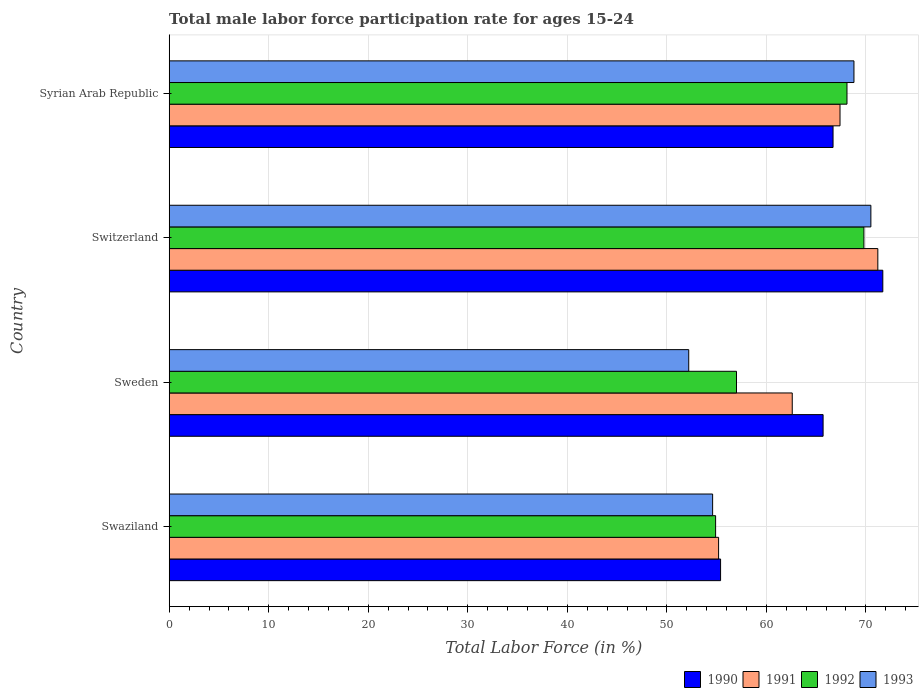How many different coloured bars are there?
Ensure brevity in your answer.  4. How many groups of bars are there?
Offer a very short reply. 4. Are the number of bars on each tick of the Y-axis equal?
Offer a terse response. Yes. What is the label of the 1st group of bars from the top?
Provide a succinct answer. Syrian Arab Republic. In how many cases, is the number of bars for a given country not equal to the number of legend labels?
Offer a very short reply. 0. What is the male labor force participation rate in 1990 in Swaziland?
Make the answer very short. 55.4. Across all countries, what is the maximum male labor force participation rate in 1992?
Offer a terse response. 69.8. Across all countries, what is the minimum male labor force participation rate in 1990?
Offer a very short reply. 55.4. In which country was the male labor force participation rate in 1990 maximum?
Your answer should be compact. Switzerland. In which country was the male labor force participation rate in 1990 minimum?
Make the answer very short. Swaziland. What is the total male labor force participation rate in 1991 in the graph?
Provide a succinct answer. 256.4. What is the difference between the male labor force participation rate in 1992 in Sweden and that in Syrian Arab Republic?
Your answer should be compact. -11.1. What is the difference between the male labor force participation rate in 1990 in Switzerland and the male labor force participation rate in 1991 in Swaziland?
Offer a terse response. 16.5. What is the average male labor force participation rate in 1993 per country?
Your response must be concise. 61.53. What is the difference between the male labor force participation rate in 1991 and male labor force participation rate in 1993 in Swaziland?
Provide a short and direct response. 0.6. What is the ratio of the male labor force participation rate in 1992 in Switzerland to that in Syrian Arab Republic?
Provide a succinct answer. 1.02. What is the difference between the highest and the second highest male labor force participation rate in 1993?
Make the answer very short. 1.7. What is the difference between the highest and the lowest male labor force participation rate in 1992?
Your answer should be compact. 14.9. In how many countries, is the male labor force participation rate in 1991 greater than the average male labor force participation rate in 1991 taken over all countries?
Offer a very short reply. 2. Is it the case that in every country, the sum of the male labor force participation rate in 1991 and male labor force participation rate in 1990 is greater than the sum of male labor force participation rate in 1993 and male labor force participation rate in 1992?
Your answer should be very brief. Yes. What does the 4th bar from the top in Sweden represents?
Your answer should be very brief. 1990. What does the 3rd bar from the bottom in Syrian Arab Republic represents?
Your answer should be compact. 1992. How many bars are there?
Your answer should be compact. 16. Does the graph contain any zero values?
Your answer should be compact. No. Does the graph contain grids?
Give a very brief answer. Yes. Where does the legend appear in the graph?
Ensure brevity in your answer.  Bottom right. How many legend labels are there?
Provide a succinct answer. 4. What is the title of the graph?
Keep it short and to the point. Total male labor force participation rate for ages 15-24. Does "1975" appear as one of the legend labels in the graph?
Give a very brief answer. No. What is the Total Labor Force (in %) of 1990 in Swaziland?
Offer a terse response. 55.4. What is the Total Labor Force (in %) in 1991 in Swaziland?
Give a very brief answer. 55.2. What is the Total Labor Force (in %) in 1992 in Swaziland?
Your response must be concise. 54.9. What is the Total Labor Force (in %) in 1993 in Swaziland?
Keep it short and to the point. 54.6. What is the Total Labor Force (in %) in 1990 in Sweden?
Make the answer very short. 65.7. What is the Total Labor Force (in %) in 1991 in Sweden?
Keep it short and to the point. 62.6. What is the Total Labor Force (in %) of 1992 in Sweden?
Offer a very short reply. 57. What is the Total Labor Force (in %) in 1993 in Sweden?
Your response must be concise. 52.2. What is the Total Labor Force (in %) of 1990 in Switzerland?
Make the answer very short. 71.7. What is the Total Labor Force (in %) in 1991 in Switzerland?
Make the answer very short. 71.2. What is the Total Labor Force (in %) of 1992 in Switzerland?
Your answer should be very brief. 69.8. What is the Total Labor Force (in %) of 1993 in Switzerland?
Your answer should be very brief. 70.5. What is the Total Labor Force (in %) of 1990 in Syrian Arab Republic?
Provide a short and direct response. 66.7. What is the Total Labor Force (in %) in 1991 in Syrian Arab Republic?
Provide a succinct answer. 67.4. What is the Total Labor Force (in %) in 1992 in Syrian Arab Republic?
Give a very brief answer. 68.1. What is the Total Labor Force (in %) in 1993 in Syrian Arab Republic?
Your response must be concise. 68.8. Across all countries, what is the maximum Total Labor Force (in %) of 1990?
Make the answer very short. 71.7. Across all countries, what is the maximum Total Labor Force (in %) of 1991?
Your answer should be very brief. 71.2. Across all countries, what is the maximum Total Labor Force (in %) of 1992?
Your answer should be very brief. 69.8. Across all countries, what is the maximum Total Labor Force (in %) in 1993?
Provide a succinct answer. 70.5. Across all countries, what is the minimum Total Labor Force (in %) in 1990?
Make the answer very short. 55.4. Across all countries, what is the minimum Total Labor Force (in %) in 1991?
Give a very brief answer. 55.2. Across all countries, what is the minimum Total Labor Force (in %) in 1992?
Offer a terse response. 54.9. Across all countries, what is the minimum Total Labor Force (in %) of 1993?
Make the answer very short. 52.2. What is the total Total Labor Force (in %) in 1990 in the graph?
Your answer should be very brief. 259.5. What is the total Total Labor Force (in %) in 1991 in the graph?
Ensure brevity in your answer.  256.4. What is the total Total Labor Force (in %) of 1992 in the graph?
Your answer should be very brief. 249.8. What is the total Total Labor Force (in %) of 1993 in the graph?
Your response must be concise. 246.1. What is the difference between the Total Labor Force (in %) in 1991 in Swaziland and that in Sweden?
Ensure brevity in your answer.  -7.4. What is the difference between the Total Labor Force (in %) in 1990 in Swaziland and that in Switzerland?
Offer a terse response. -16.3. What is the difference between the Total Labor Force (in %) of 1991 in Swaziland and that in Switzerland?
Ensure brevity in your answer.  -16. What is the difference between the Total Labor Force (in %) in 1992 in Swaziland and that in Switzerland?
Your answer should be compact. -14.9. What is the difference between the Total Labor Force (in %) of 1993 in Swaziland and that in Switzerland?
Provide a succinct answer. -15.9. What is the difference between the Total Labor Force (in %) in 1991 in Sweden and that in Switzerland?
Your answer should be very brief. -8.6. What is the difference between the Total Labor Force (in %) in 1992 in Sweden and that in Switzerland?
Keep it short and to the point. -12.8. What is the difference between the Total Labor Force (in %) in 1993 in Sweden and that in Switzerland?
Provide a short and direct response. -18.3. What is the difference between the Total Labor Force (in %) in 1990 in Sweden and that in Syrian Arab Republic?
Keep it short and to the point. -1. What is the difference between the Total Labor Force (in %) in 1991 in Sweden and that in Syrian Arab Republic?
Offer a terse response. -4.8. What is the difference between the Total Labor Force (in %) in 1992 in Sweden and that in Syrian Arab Republic?
Provide a short and direct response. -11.1. What is the difference between the Total Labor Force (in %) of 1993 in Sweden and that in Syrian Arab Republic?
Provide a succinct answer. -16.6. What is the difference between the Total Labor Force (in %) in 1990 in Switzerland and that in Syrian Arab Republic?
Give a very brief answer. 5. What is the difference between the Total Labor Force (in %) of 1991 in Switzerland and that in Syrian Arab Republic?
Ensure brevity in your answer.  3.8. What is the difference between the Total Labor Force (in %) in 1993 in Switzerland and that in Syrian Arab Republic?
Your answer should be very brief. 1.7. What is the difference between the Total Labor Force (in %) of 1990 in Swaziland and the Total Labor Force (in %) of 1992 in Sweden?
Keep it short and to the point. -1.6. What is the difference between the Total Labor Force (in %) in 1991 in Swaziland and the Total Labor Force (in %) in 1992 in Sweden?
Your answer should be very brief. -1.8. What is the difference between the Total Labor Force (in %) in 1992 in Swaziland and the Total Labor Force (in %) in 1993 in Sweden?
Your response must be concise. 2.7. What is the difference between the Total Labor Force (in %) of 1990 in Swaziland and the Total Labor Force (in %) of 1991 in Switzerland?
Offer a terse response. -15.8. What is the difference between the Total Labor Force (in %) of 1990 in Swaziland and the Total Labor Force (in %) of 1992 in Switzerland?
Make the answer very short. -14.4. What is the difference between the Total Labor Force (in %) in 1990 in Swaziland and the Total Labor Force (in %) in 1993 in Switzerland?
Make the answer very short. -15.1. What is the difference between the Total Labor Force (in %) of 1991 in Swaziland and the Total Labor Force (in %) of 1992 in Switzerland?
Your answer should be compact. -14.6. What is the difference between the Total Labor Force (in %) of 1991 in Swaziland and the Total Labor Force (in %) of 1993 in Switzerland?
Ensure brevity in your answer.  -15.3. What is the difference between the Total Labor Force (in %) in 1992 in Swaziland and the Total Labor Force (in %) in 1993 in Switzerland?
Your answer should be very brief. -15.6. What is the difference between the Total Labor Force (in %) of 1990 in Swaziland and the Total Labor Force (in %) of 1991 in Syrian Arab Republic?
Keep it short and to the point. -12. What is the difference between the Total Labor Force (in %) in 1990 in Swaziland and the Total Labor Force (in %) in 1993 in Syrian Arab Republic?
Offer a terse response. -13.4. What is the difference between the Total Labor Force (in %) of 1992 in Swaziland and the Total Labor Force (in %) of 1993 in Syrian Arab Republic?
Make the answer very short. -13.9. What is the difference between the Total Labor Force (in %) of 1990 in Sweden and the Total Labor Force (in %) of 1991 in Switzerland?
Give a very brief answer. -5.5. What is the difference between the Total Labor Force (in %) of 1991 in Sweden and the Total Labor Force (in %) of 1992 in Switzerland?
Your answer should be very brief. -7.2. What is the difference between the Total Labor Force (in %) of 1991 in Sweden and the Total Labor Force (in %) of 1993 in Switzerland?
Your response must be concise. -7.9. What is the difference between the Total Labor Force (in %) in 1992 in Sweden and the Total Labor Force (in %) in 1993 in Switzerland?
Keep it short and to the point. -13.5. What is the difference between the Total Labor Force (in %) in 1990 in Sweden and the Total Labor Force (in %) in 1991 in Syrian Arab Republic?
Provide a short and direct response. -1.7. What is the difference between the Total Labor Force (in %) of 1990 in Sweden and the Total Labor Force (in %) of 1992 in Syrian Arab Republic?
Provide a short and direct response. -2.4. What is the difference between the Total Labor Force (in %) in 1990 in Sweden and the Total Labor Force (in %) in 1993 in Syrian Arab Republic?
Offer a terse response. -3.1. What is the difference between the Total Labor Force (in %) of 1991 in Sweden and the Total Labor Force (in %) of 1993 in Syrian Arab Republic?
Keep it short and to the point. -6.2. What is the difference between the Total Labor Force (in %) of 1990 in Switzerland and the Total Labor Force (in %) of 1992 in Syrian Arab Republic?
Your response must be concise. 3.6. What is the difference between the Total Labor Force (in %) of 1990 in Switzerland and the Total Labor Force (in %) of 1993 in Syrian Arab Republic?
Your answer should be very brief. 2.9. What is the difference between the Total Labor Force (in %) in 1991 in Switzerland and the Total Labor Force (in %) in 1992 in Syrian Arab Republic?
Your response must be concise. 3.1. What is the difference between the Total Labor Force (in %) of 1992 in Switzerland and the Total Labor Force (in %) of 1993 in Syrian Arab Republic?
Your answer should be very brief. 1. What is the average Total Labor Force (in %) in 1990 per country?
Make the answer very short. 64.88. What is the average Total Labor Force (in %) of 1991 per country?
Offer a very short reply. 64.1. What is the average Total Labor Force (in %) in 1992 per country?
Provide a short and direct response. 62.45. What is the average Total Labor Force (in %) of 1993 per country?
Provide a short and direct response. 61.52. What is the difference between the Total Labor Force (in %) of 1990 and Total Labor Force (in %) of 1991 in Swaziland?
Ensure brevity in your answer.  0.2. What is the difference between the Total Labor Force (in %) in 1991 and Total Labor Force (in %) in 1992 in Swaziland?
Provide a short and direct response. 0.3. What is the difference between the Total Labor Force (in %) of 1992 and Total Labor Force (in %) of 1993 in Swaziland?
Your answer should be very brief. 0.3. What is the difference between the Total Labor Force (in %) of 1990 and Total Labor Force (in %) of 1991 in Sweden?
Provide a succinct answer. 3.1. What is the difference between the Total Labor Force (in %) in 1990 and Total Labor Force (in %) in 1993 in Sweden?
Your answer should be compact. 13.5. What is the difference between the Total Labor Force (in %) in 1991 and Total Labor Force (in %) in 1993 in Sweden?
Provide a short and direct response. 10.4. What is the difference between the Total Labor Force (in %) of 1990 and Total Labor Force (in %) of 1992 in Switzerland?
Make the answer very short. 1.9. What is the difference between the Total Labor Force (in %) in 1991 and Total Labor Force (in %) in 1992 in Switzerland?
Offer a very short reply. 1.4. What is the difference between the Total Labor Force (in %) in 1990 and Total Labor Force (in %) in 1993 in Syrian Arab Republic?
Offer a terse response. -2.1. What is the difference between the Total Labor Force (in %) in 1991 and Total Labor Force (in %) in 1992 in Syrian Arab Republic?
Your response must be concise. -0.7. What is the difference between the Total Labor Force (in %) in 1991 and Total Labor Force (in %) in 1993 in Syrian Arab Republic?
Keep it short and to the point. -1.4. What is the difference between the Total Labor Force (in %) of 1992 and Total Labor Force (in %) of 1993 in Syrian Arab Republic?
Provide a short and direct response. -0.7. What is the ratio of the Total Labor Force (in %) in 1990 in Swaziland to that in Sweden?
Keep it short and to the point. 0.84. What is the ratio of the Total Labor Force (in %) in 1991 in Swaziland to that in Sweden?
Ensure brevity in your answer.  0.88. What is the ratio of the Total Labor Force (in %) in 1992 in Swaziland to that in Sweden?
Provide a short and direct response. 0.96. What is the ratio of the Total Labor Force (in %) in 1993 in Swaziland to that in Sweden?
Make the answer very short. 1.05. What is the ratio of the Total Labor Force (in %) of 1990 in Swaziland to that in Switzerland?
Your answer should be very brief. 0.77. What is the ratio of the Total Labor Force (in %) in 1991 in Swaziland to that in Switzerland?
Your answer should be very brief. 0.78. What is the ratio of the Total Labor Force (in %) of 1992 in Swaziland to that in Switzerland?
Give a very brief answer. 0.79. What is the ratio of the Total Labor Force (in %) in 1993 in Swaziland to that in Switzerland?
Offer a terse response. 0.77. What is the ratio of the Total Labor Force (in %) in 1990 in Swaziland to that in Syrian Arab Republic?
Your answer should be compact. 0.83. What is the ratio of the Total Labor Force (in %) in 1991 in Swaziland to that in Syrian Arab Republic?
Make the answer very short. 0.82. What is the ratio of the Total Labor Force (in %) in 1992 in Swaziland to that in Syrian Arab Republic?
Your answer should be compact. 0.81. What is the ratio of the Total Labor Force (in %) in 1993 in Swaziland to that in Syrian Arab Republic?
Provide a short and direct response. 0.79. What is the ratio of the Total Labor Force (in %) in 1990 in Sweden to that in Switzerland?
Make the answer very short. 0.92. What is the ratio of the Total Labor Force (in %) of 1991 in Sweden to that in Switzerland?
Make the answer very short. 0.88. What is the ratio of the Total Labor Force (in %) of 1992 in Sweden to that in Switzerland?
Give a very brief answer. 0.82. What is the ratio of the Total Labor Force (in %) of 1993 in Sweden to that in Switzerland?
Your answer should be very brief. 0.74. What is the ratio of the Total Labor Force (in %) of 1991 in Sweden to that in Syrian Arab Republic?
Keep it short and to the point. 0.93. What is the ratio of the Total Labor Force (in %) of 1992 in Sweden to that in Syrian Arab Republic?
Ensure brevity in your answer.  0.84. What is the ratio of the Total Labor Force (in %) of 1993 in Sweden to that in Syrian Arab Republic?
Offer a terse response. 0.76. What is the ratio of the Total Labor Force (in %) in 1990 in Switzerland to that in Syrian Arab Republic?
Ensure brevity in your answer.  1.07. What is the ratio of the Total Labor Force (in %) in 1991 in Switzerland to that in Syrian Arab Republic?
Keep it short and to the point. 1.06. What is the ratio of the Total Labor Force (in %) in 1993 in Switzerland to that in Syrian Arab Republic?
Provide a short and direct response. 1.02. What is the difference between the highest and the second highest Total Labor Force (in %) of 1992?
Your answer should be compact. 1.7. What is the difference between the highest and the lowest Total Labor Force (in %) in 1992?
Make the answer very short. 14.9. What is the difference between the highest and the lowest Total Labor Force (in %) in 1993?
Provide a succinct answer. 18.3. 